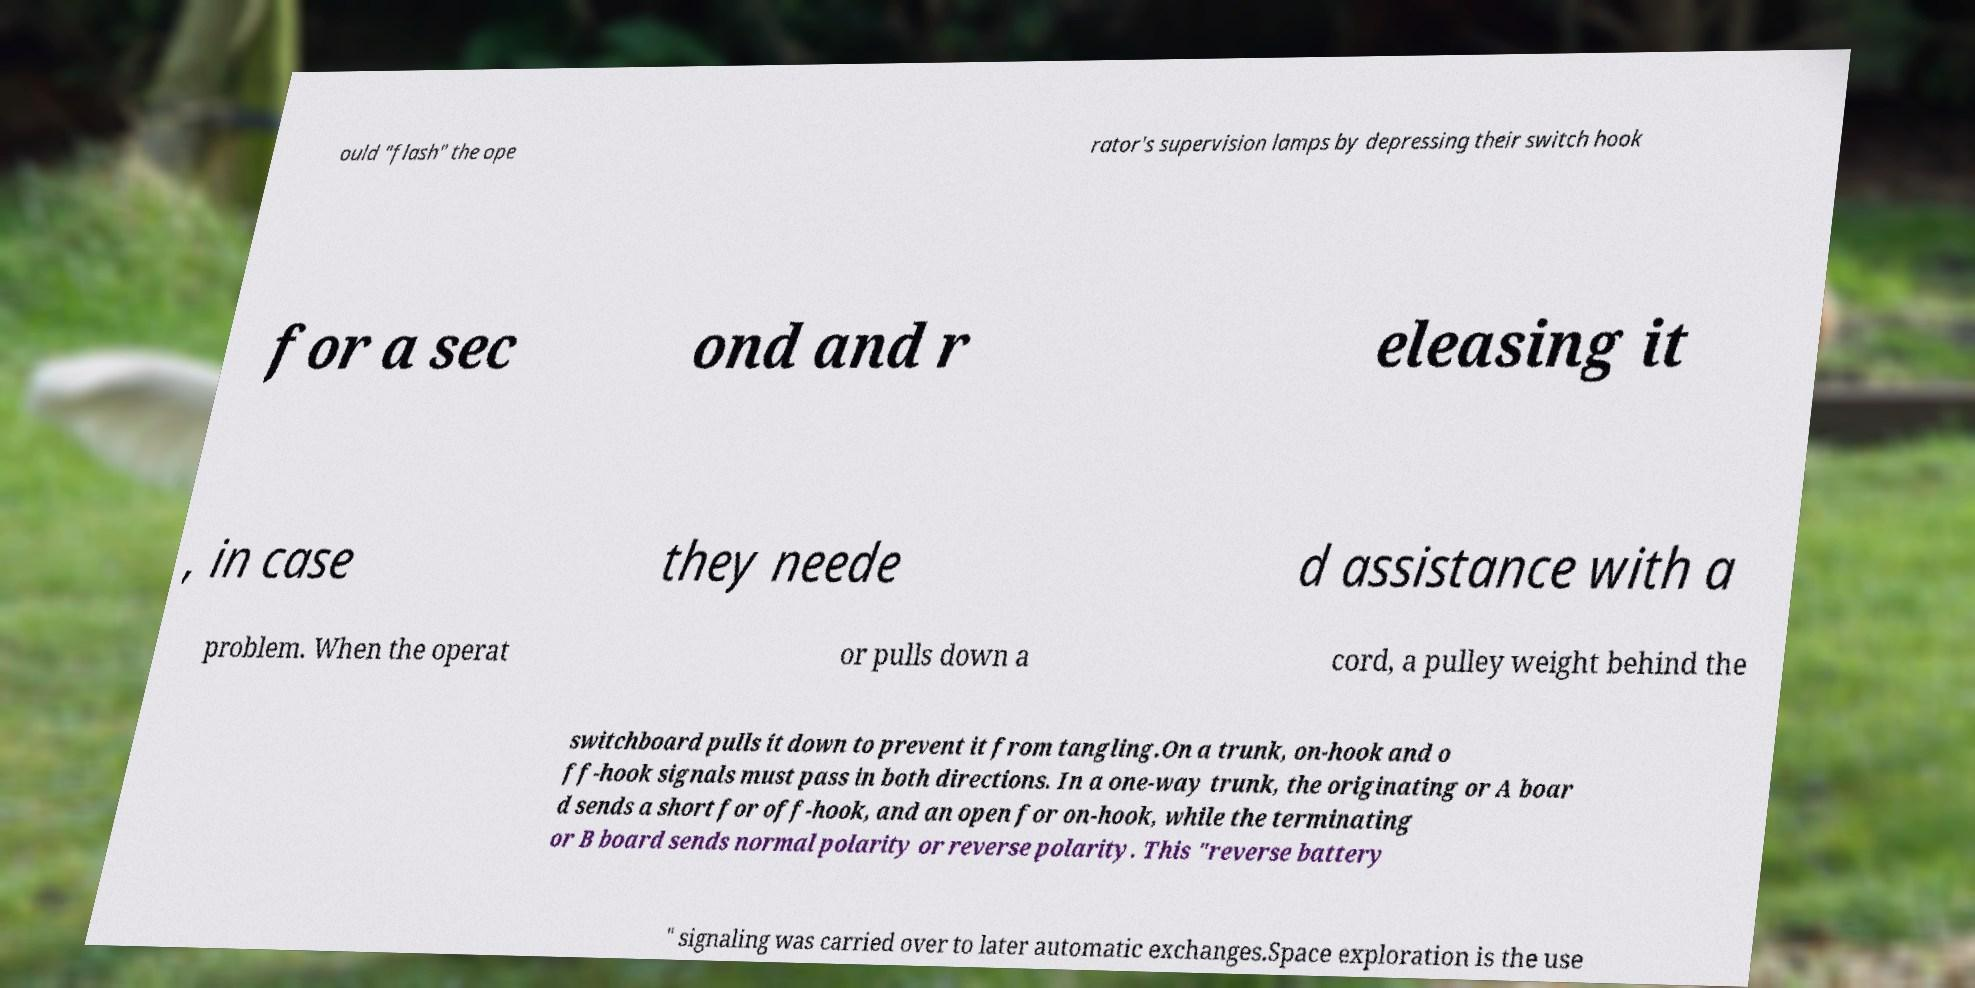Please read and relay the text visible in this image. What does it say? ould "flash" the ope rator's supervision lamps by depressing their switch hook for a sec ond and r eleasing it , in case they neede d assistance with a problem. When the operat or pulls down a cord, a pulley weight behind the switchboard pulls it down to prevent it from tangling.On a trunk, on-hook and o ff-hook signals must pass in both directions. In a one-way trunk, the originating or A boar d sends a short for off-hook, and an open for on-hook, while the terminating or B board sends normal polarity or reverse polarity. This "reverse battery " signaling was carried over to later automatic exchanges.Space exploration is the use 